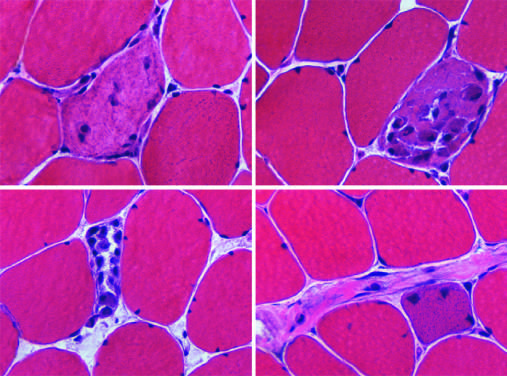what are regenerative myofibers characterized by?
Answer the question using a single word or phrase. Cytoplasmic basophilia and enlarged nucleoli 